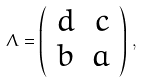<formula> <loc_0><loc_0><loc_500><loc_500>\Lambda = \left ( \begin{array} { r r } d & c \\ b & a \\ \end{array} \right ) \, ,</formula> 